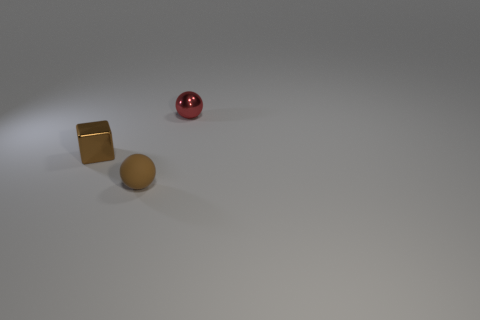How would you describe the lighting in the scene? The lighting in the scene is soft and diffused, characterized by a gentle gradation of shadows that suggests a subtle light source. It creates an atmospheric effect that highlights the objects with a slight gleam, particularly noticeable on the surfaces of the metallic and spherical objects. 